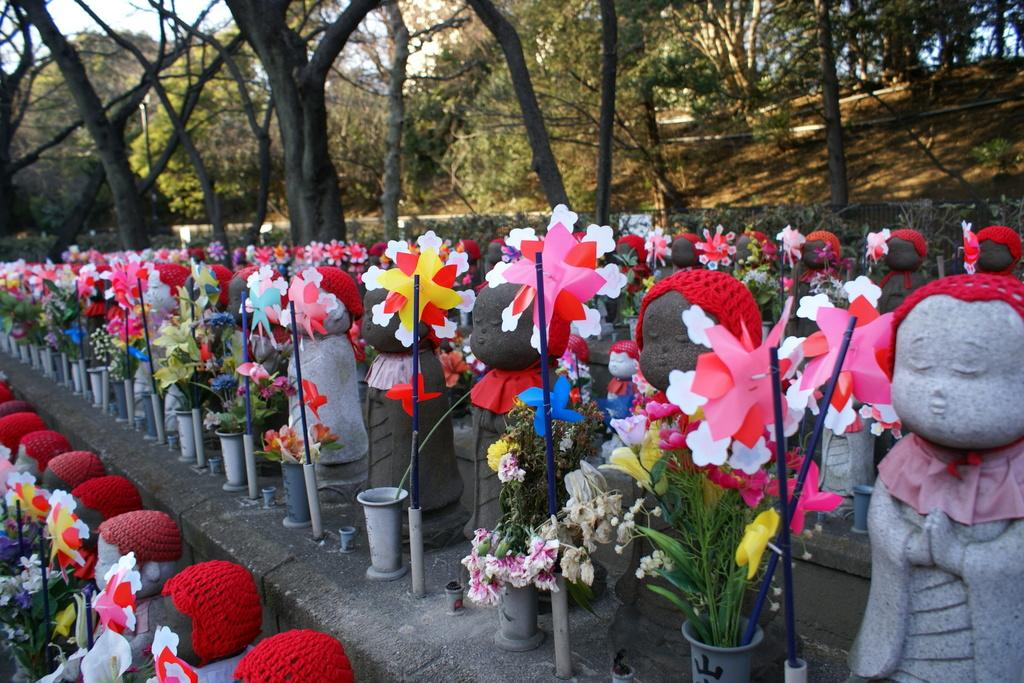What type of objects can be seen in the image? There are statues and flower vases in the image. What can be seen in the background of the image? There are trees and the sky visible in the background of the image. Can you see any cobwebs on the statues in the image? There is no mention of cobwebs in the image, so it cannot be determined if any are present. What type of unit is being measured in the image? There is no indication of any unit being measured in the image. 